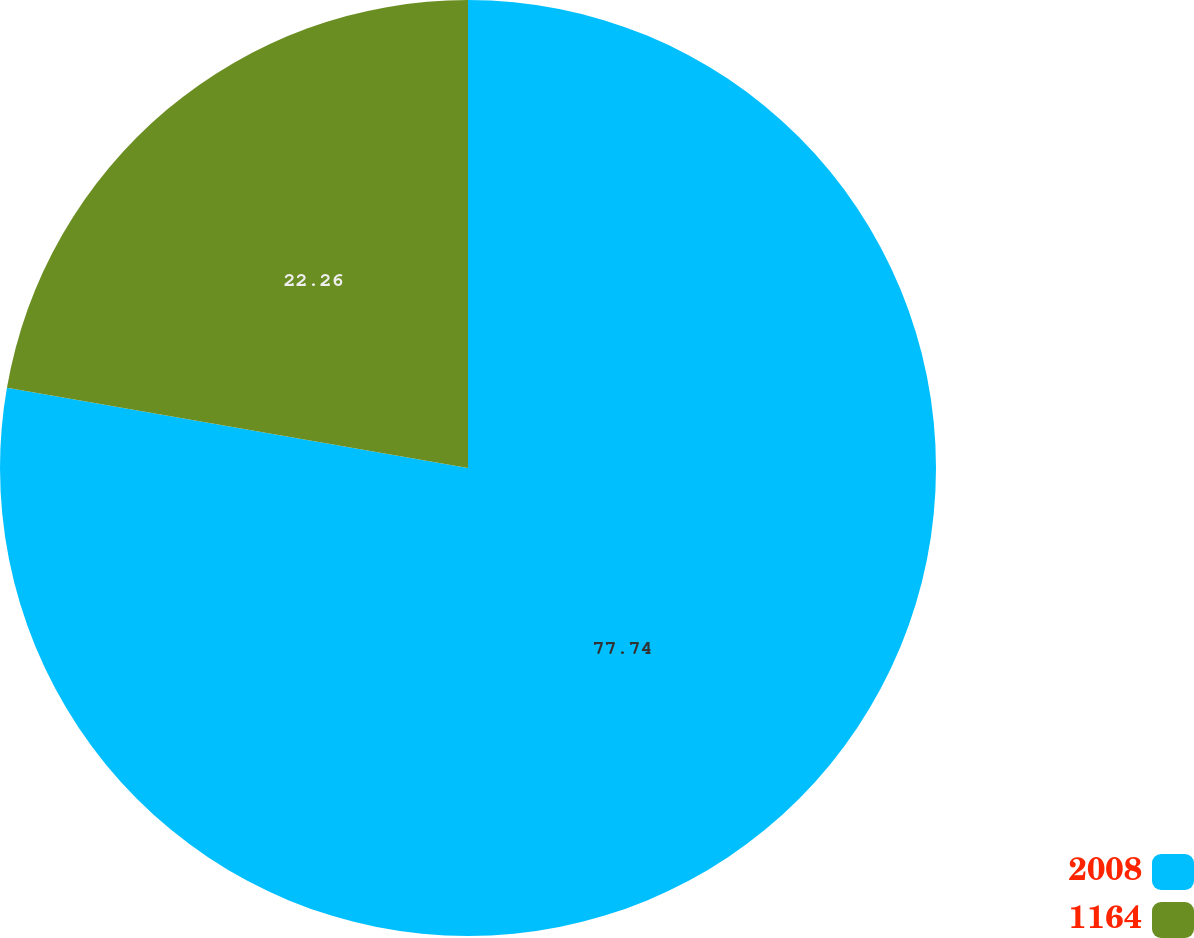Convert chart to OTSL. <chart><loc_0><loc_0><loc_500><loc_500><pie_chart><fcel>2008<fcel>1164<nl><fcel>77.74%<fcel>22.26%<nl></chart> 